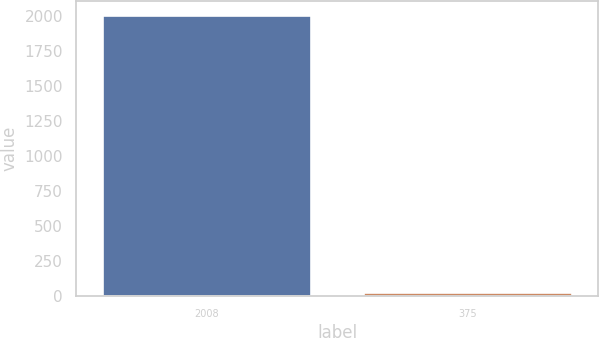Convert chart to OTSL. <chart><loc_0><loc_0><loc_500><loc_500><bar_chart><fcel>2008<fcel>375<nl><fcel>2010<fcel>27<nl></chart> 